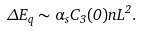Convert formula to latex. <formula><loc_0><loc_0><loc_500><loc_500>\Delta E _ { q } \sim \alpha _ { s } C _ { 3 } ( 0 ) n L ^ { 2 } .</formula> 